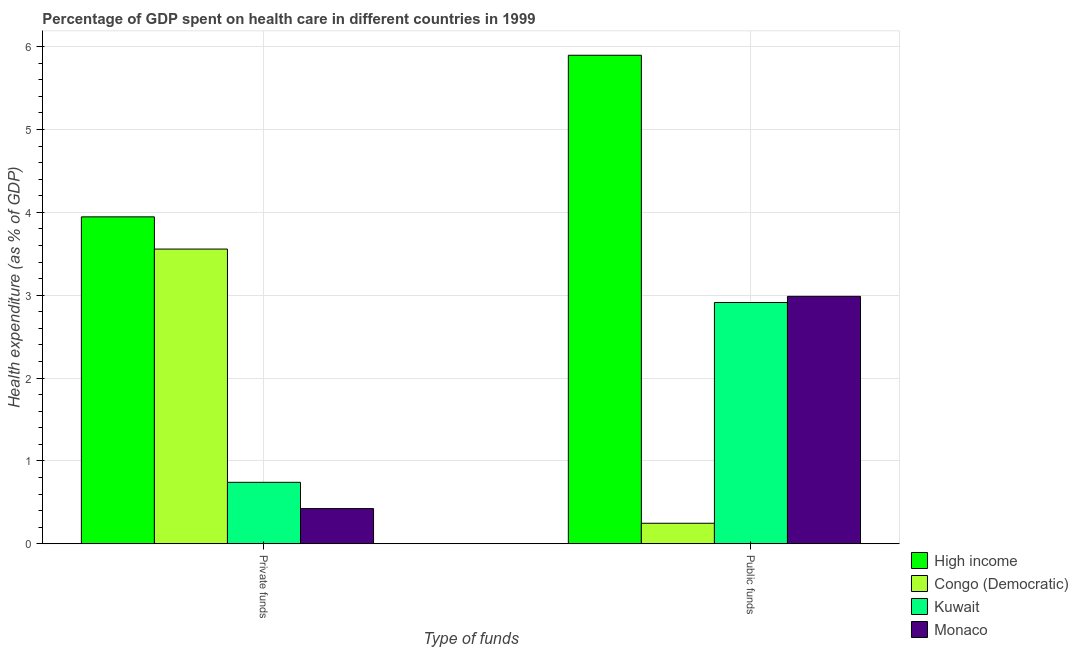How many different coloured bars are there?
Make the answer very short. 4. What is the label of the 1st group of bars from the left?
Your response must be concise. Private funds. What is the amount of public funds spent in healthcare in Kuwait?
Make the answer very short. 2.91. Across all countries, what is the maximum amount of private funds spent in healthcare?
Provide a succinct answer. 3.95. Across all countries, what is the minimum amount of public funds spent in healthcare?
Give a very brief answer. 0.25. In which country was the amount of public funds spent in healthcare maximum?
Ensure brevity in your answer.  High income. In which country was the amount of private funds spent in healthcare minimum?
Your answer should be compact. Monaco. What is the total amount of private funds spent in healthcare in the graph?
Your answer should be compact. 8.67. What is the difference between the amount of private funds spent in healthcare in High income and that in Monaco?
Provide a short and direct response. 3.52. What is the difference between the amount of public funds spent in healthcare in Kuwait and the amount of private funds spent in healthcare in High income?
Your answer should be compact. -1.03. What is the average amount of private funds spent in healthcare per country?
Provide a succinct answer. 2.17. What is the difference between the amount of public funds spent in healthcare and amount of private funds spent in healthcare in Kuwait?
Offer a terse response. 2.17. In how many countries, is the amount of public funds spent in healthcare greater than 3.8 %?
Provide a succinct answer. 1. What is the ratio of the amount of private funds spent in healthcare in Monaco to that in Kuwait?
Make the answer very short. 0.57. What does the 4th bar from the left in Private funds represents?
Offer a very short reply. Monaco. What does the 1st bar from the right in Private funds represents?
Keep it short and to the point. Monaco. How many bars are there?
Your answer should be compact. 8. Are the values on the major ticks of Y-axis written in scientific E-notation?
Offer a terse response. No. Does the graph contain any zero values?
Offer a very short reply. No. Does the graph contain grids?
Ensure brevity in your answer.  Yes. Where does the legend appear in the graph?
Give a very brief answer. Bottom right. How many legend labels are there?
Keep it short and to the point. 4. What is the title of the graph?
Offer a very short reply. Percentage of GDP spent on health care in different countries in 1999. What is the label or title of the X-axis?
Your answer should be very brief. Type of funds. What is the label or title of the Y-axis?
Provide a short and direct response. Health expenditure (as % of GDP). What is the Health expenditure (as % of GDP) of High income in Private funds?
Provide a short and direct response. 3.95. What is the Health expenditure (as % of GDP) in Congo (Democratic) in Private funds?
Your response must be concise. 3.56. What is the Health expenditure (as % of GDP) in Kuwait in Private funds?
Provide a short and direct response. 0.74. What is the Health expenditure (as % of GDP) in Monaco in Private funds?
Offer a terse response. 0.42. What is the Health expenditure (as % of GDP) of High income in Public funds?
Give a very brief answer. 5.9. What is the Health expenditure (as % of GDP) in Congo (Democratic) in Public funds?
Provide a short and direct response. 0.25. What is the Health expenditure (as % of GDP) in Kuwait in Public funds?
Provide a succinct answer. 2.91. What is the Health expenditure (as % of GDP) of Monaco in Public funds?
Your response must be concise. 2.99. Across all Type of funds, what is the maximum Health expenditure (as % of GDP) in High income?
Offer a very short reply. 5.9. Across all Type of funds, what is the maximum Health expenditure (as % of GDP) of Congo (Democratic)?
Make the answer very short. 3.56. Across all Type of funds, what is the maximum Health expenditure (as % of GDP) in Kuwait?
Provide a succinct answer. 2.91. Across all Type of funds, what is the maximum Health expenditure (as % of GDP) in Monaco?
Make the answer very short. 2.99. Across all Type of funds, what is the minimum Health expenditure (as % of GDP) in High income?
Provide a succinct answer. 3.95. Across all Type of funds, what is the minimum Health expenditure (as % of GDP) in Congo (Democratic)?
Keep it short and to the point. 0.25. Across all Type of funds, what is the minimum Health expenditure (as % of GDP) of Kuwait?
Provide a succinct answer. 0.74. Across all Type of funds, what is the minimum Health expenditure (as % of GDP) in Monaco?
Make the answer very short. 0.42. What is the total Health expenditure (as % of GDP) in High income in the graph?
Your response must be concise. 9.84. What is the total Health expenditure (as % of GDP) in Congo (Democratic) in the graph?
Keep it short and to the point. 3.8. What is the total Health expenditure (as % of GDP) in Kuwait in the graph?
Ensure brevity in your answer.  3.65. What is the total Health expenditure (as % of GDP) in Monaco in the graph?
Your answer should be compact. 3.41. What is the difference between the Health expenditure (as % of GDP) in High income in Private funds and that in Public funds?
Give a very brief answer. -1.95. What is the difference between the Health expenditure (as % of GDP) in Congo (Democratic) in Private funds and that in Public funds?
Ensure brevity in your answer.  3.31. What is the difference between the Health expenditure (as % of GDP) of Kuwait in Private funds and that in Public funds?
Provide a short and direct response. -2.17. What is the difference between the Health expenditure (as % of GDP) in Monaco in Private funds and that in Public funds?
Make the answer very short. -2.56. What is the difference between the Health expenditure (as % of GDP) of High income in Private funds and the Health expenditure (as % of GDP) of Congo (Democratic) in Public funds?
Keep it short and to the point. 3.7. What is the difference between the Health expenditure (as % of GDP) in High income in Private funds and the Health expenditure (as % of GDP) in Kuwait in Public funds?
Offer a very short reply. 1.03. What is the difference between the Health expenditure (as % of GDP) of High income in Private funds and the Health expenditure (as % of GDP) of Monaco in Public funds?
Your answer should be very brief. 0.96. What is the difference between the Health expenditure (as % of GDP) of Congo (Democratic) in Private funds and the Health expenditure (as % of GDP) of Kuwait in Public funds?
Your response must be concise. 0.64. What is the difference between the Health expenditure (as % of GDP) of Congo (Democratic) in Private funds and the Health expenditure (as % of GDP) of Monaco in Public funds?
Provide a succinct answer. 0.57. What is the difference between the Health expenditure (as % of GDP) of Kuwait in Private funds and the Health expenditure (as % of GDP) of Monaco in Public funds?
Offer a very short reply. -2.24. What is the average Health expenditure (as % of GDP) in High income per Type of funds?
Your response must be concise. 4.92. What is the average Health expenditure (as % of GDP) in Congo (Democratic) per Type of funds?
Your answer should be compact. 1.9. What is the average Health expenditure (as % of GDP) in Kuwait per Type of funds?
Offer a very short reply. 1.83. What is the average Health expenditure (as % of GDP) in Monaco per Type of funds?
Offer a terse response. 1.71. What is the difference between the Health expenditure (as % of GDP) of High income and Health expenditure (as % of GDP) of Congo (Democratic) in Private funds?
Provide a short and direct response. 0.39. What is the difference between the Health expenditure (as % of GDP) of High income and Health expenditure (as % of GDP) of Kuwait in Private funds?
Keep it short and to the point. 3.2. What is the difference between the Health expenditure (as % of GDP) of High income and Health expenditure (as % of GDP) of Monaco in Private funds?
Give a very brief answer. 3.52. What is the difference between the Health expenditure (as % of GDP) in Congo (Democratic) and Health expenditure (as % of GDP) in Kuwait in Private funds?
Make the answer very short. 2.81. What is the difference between the Health expenditure (as % of GDP) in Congo (Democratic) and Health expenditure (as % of GDP) in Monaco in Private funds?
Ensure brevity in your answer.  3.13. What is the difference between the Health expenditure (as % of GDP) in Kuwait and Health expenditure (as % of GDP) in Monaco in Private funds?
Make the answer very short. 0.32. What is the difference between the Health expenditure (as % of GDP) of High income and Health expenditure (as % of GDP) of Congo (Democratic) in Public funds?
Give a very brief answer. 5.65. What is the difference between the Health expenditure (as % of GDP) of High income and Health expenditure (as % of GDP) of Kuwait in Public funds?
Ensure brevity in your answer.  2.98. What is the difference between the Health expenditure (as % of GDP) of High income and Health expenditure (as % of GDP) of Monaco in Public funds?
Give a very brief answer. 2.91. What is the difference between the Health expenditure (as % of GDP) in Congo (Democratic) and Health expenditure (as % of GDP) in Kuwait in Public funds?
Ensure brevity in your answer.  -2.66. What is the difference between the Health expenditure (as % of GDP) in Congo (Democratic) and Health expenditure (as % of GDP) in Monaco in Public funds?
Make the answer very short. -2.74. What is the difference between the Health expenditure (as % of GDP) of Kuwait and Health expenditure (as % of GDP) of Monaco in Public funds?
Make the answer very short. -0.07. What is the ratio of the Health expenditure (as % of GDP) in High income in Private funds to that in Public funds?
Make the answer very short. 0.67. What is the ratio of the Health expenditure (as % of GDP) of Congo (Democratic) in Private funds to that in Public funds?
Ensure brevity in your answer.  14.36. What is the ratio of the Health expenditure (as % of GDP) of Kuwait in Private funds to that in Public funds?
Keep it short and to the point. 0.25. What is the ratio of the Health expenditure (as % of GDP) in Monaco in Private funds to that in Public funds?
Give a very brief answer. 0.14. What is the difference between the highest and the second highest Health expenditure (as % of GDP) of High income?
Keep it short and to the point. 1.95. What is the difference between the highest and the second highest Health expenditure (as % of GDP) of Congo (Democratic)?
Make the answer very short. 3.31. What is the difference between the highest and the second highest Health expenditure (as % of GDP) in Kuwait?
Provide a short and direct response. 2.17. What is the difference between the highest and the second highest Health expenditure (as % of GDP) of Monaco?
Your response must be concise. 2.56. What is the difference between the highest and the lowest Health expenditure (as % of GDP) in High income?
Make the answer very short. 1.95. What is the difference between the highest and the lowest Health expenditure (as % of GDP) in Congo (Democratic)?
Keep it short and to the point. 3.31. What is the difference between the highest and the lowest Health expenditure (as % of GDP) in Kuwait?
Offer a very short reply. 2.17. What is the difference between the highest and the lowest Health expenditure (as % of GDP) in Monaco?
Provide a short and direct response. 2.56. 